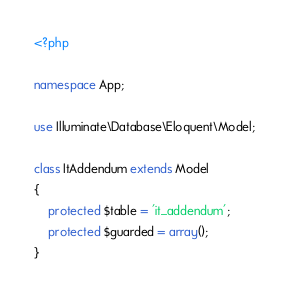<code> <loc_0><loc_0><loc_500><loc_500><_PHP_><?php

namespace App;

use Illuminate\Database\Eloquent\Model;

class ItAddendum extends Model
{
    protected $table = 'it_addendum';
    protected $guarded = array();
}
</code> 